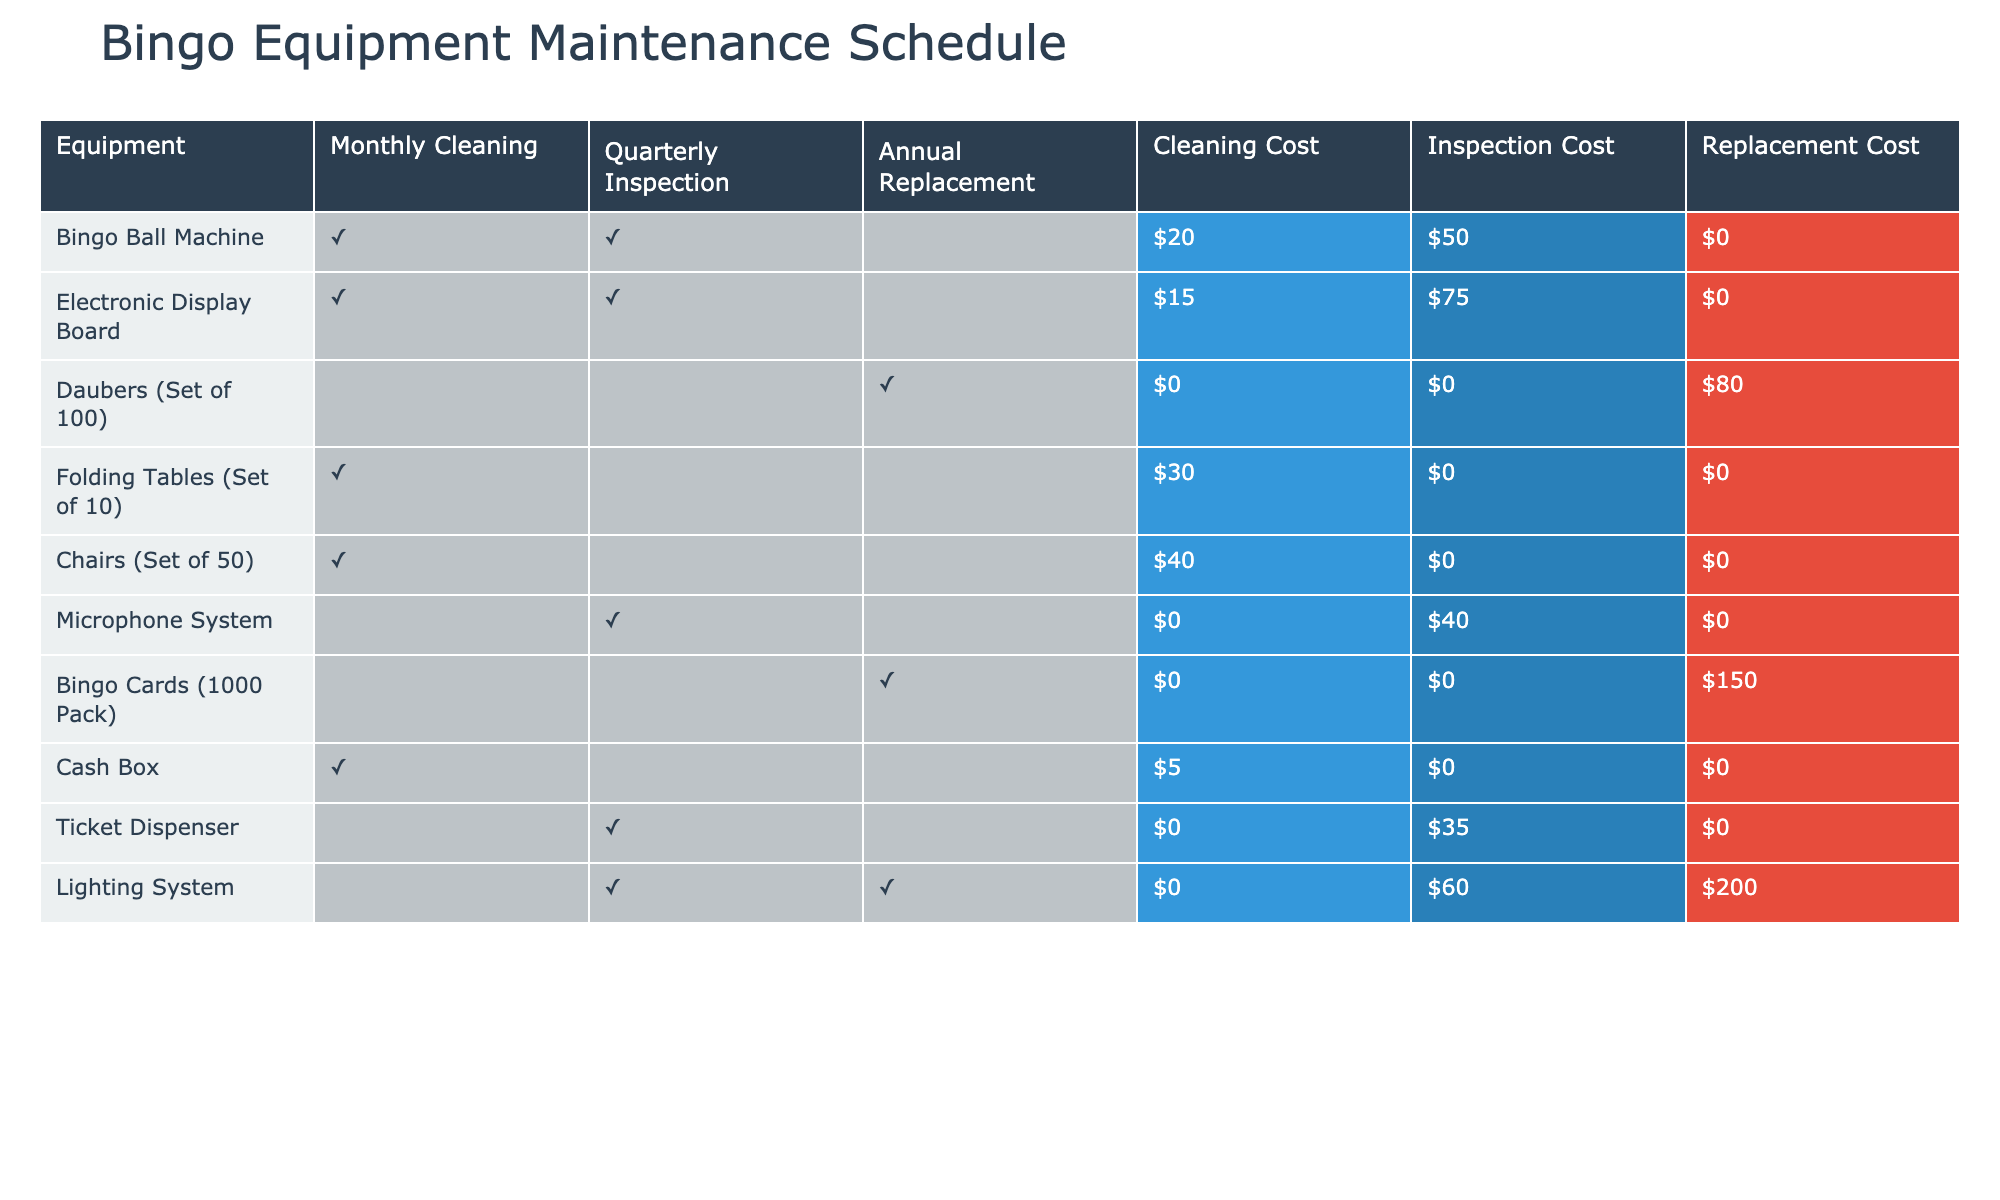What's the cleaning cost for the Bingo Ball Machine? According to the table, the cleaning cost for the Bingo Ball Machine is listed as $20.
Answer: $20 How many pieces of equipment require quarterly inspection? By examining the table, we see that the Bingo Ball Machine, Electronic Display Board, Microphone System, and Ticket Dispenser all require quarterly inspection, totaling 4 pieces of equipment.
Answer: 4 Is the Daubers (Set of 100) subject to monthly cleaning? The table specifies that the Daubers (Set of 100) does not require monthly cleaning (indicated by FALSE).
Answer: No What is the total replacement cost for all equipment listed? From the table, we sum the replacement costs: $0 (Bingo Ball Machine) + $0 (Electronic Display Board) + $80 (Daubers) + $0 (Folding Tables) + $0 (Chairs) + $0 (Microphone System) + $150 (Bingo Cards) + $0 (Cash Box) + $0 (Ticket Dispenser) + $200 (Lighting System) = $430 total replacement cost.
Answer: $430 Which equipment has the highest annual replacement cost? Looking at the table, the Light System has the highest annual replacement cost of $200, compared to all other equipment, which have lower or zero costs.
Answer: Lighting System Do any items require both monthly cleaning and quarterly inspection? Reviewing the table, both the Bingo Ball Machine and the Electronic Display Board have TRUE for both monthly cleaning and quarterly inspection.
Answer: Yes What's the average cleaning cost of all equipment? The total cleaning costs are $20 + $15 + $0 + $30 + $40 + $0 + $0 + $5 + $0 + $0 = $110. There are 10 pieces of equipment, so the average cleaning cost is $110 / 10 = $11.
Answer: $11 How many items are there that do not require any form of maintenance? After checking the table, the Daubers (Set of 100) and Bingo Cards (1000 Pack) are not subject to monthly cleaning, quarterly inspection, or annual replacement. Therefore, there are 2 items that require no maintenance.
Answer: 2 Which equipment has the lowest inspection cost? The table shows that the Cash Box has the lowest inspection cost at $0, as all other pieces either have a higher cost or also $0.
Answer: Cash Box 